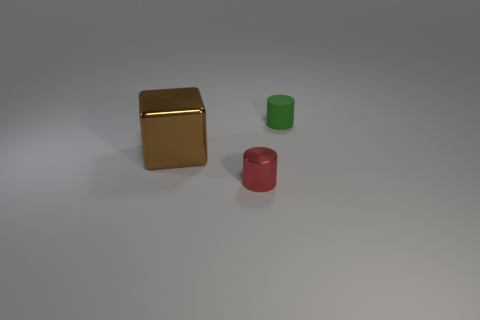Add 3 small rubber objects. How many objects exist? 6 Subtract all cubes. How many objects are left? 2 Add 1 blue rubber balls. How many blue rubber balls exist? 1 Subtract 0 brown spheres. How many objects are left? 3 Subtract all red shiny things. Subtract all brown metallic blocks. How many objects are left? 1 Add 2 big metal things. How many big metal things are left? 3 